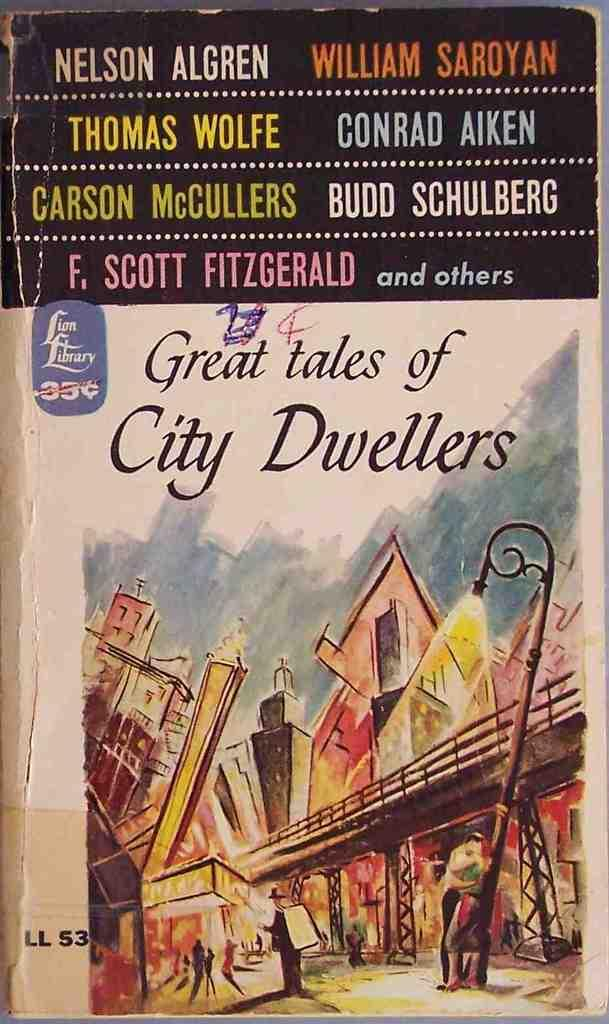<image>
Give a short and clear explanation of the subsequent image. A poster for the movie Great Tales of City Dwellers. 